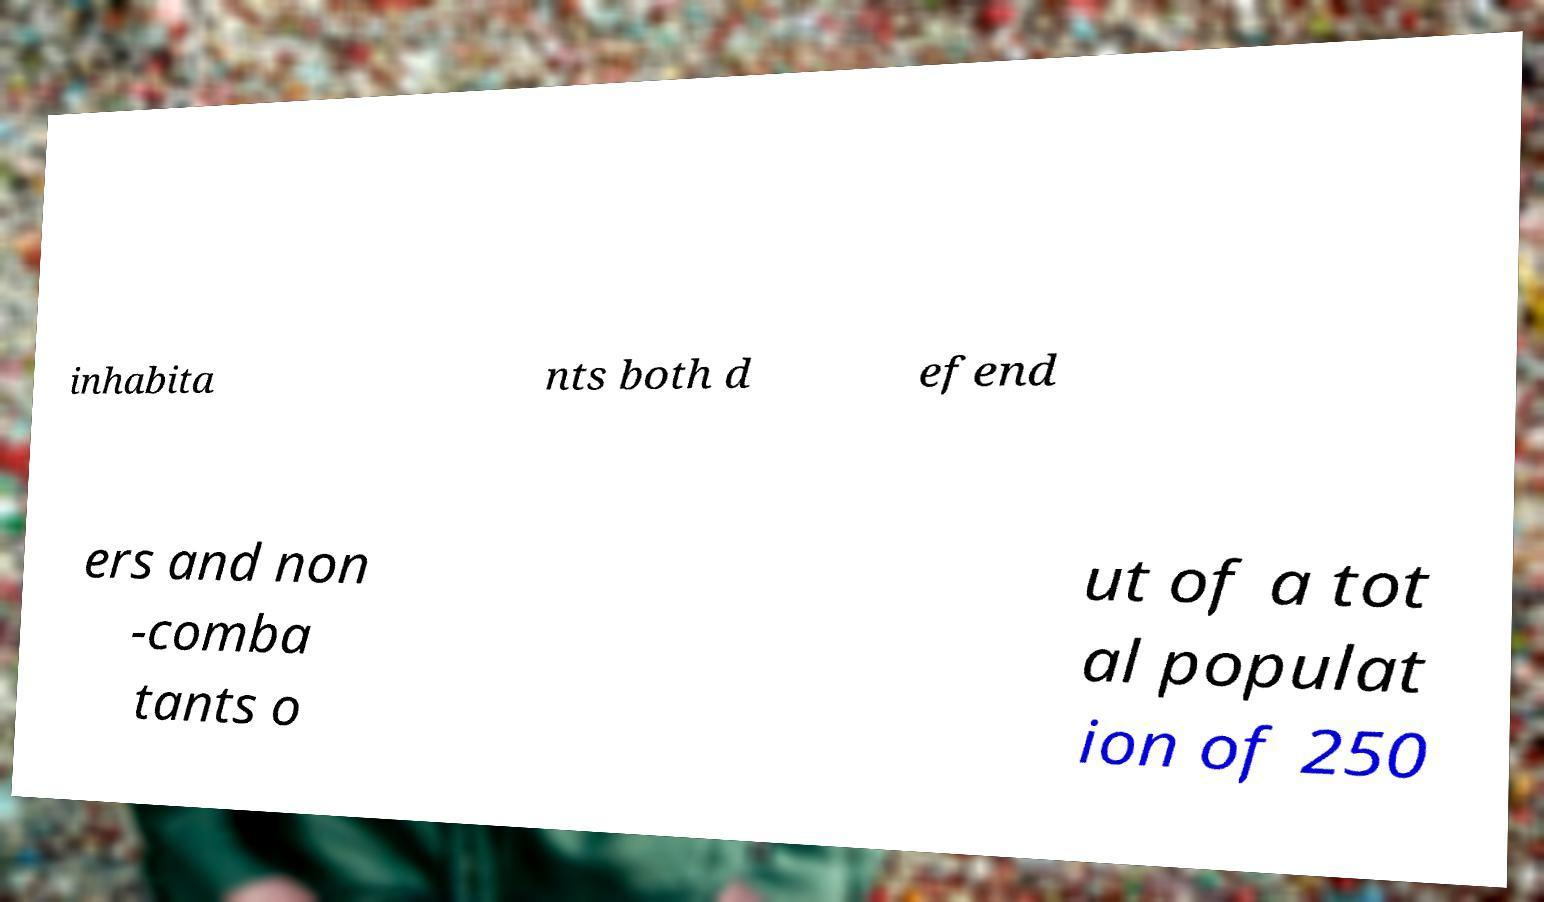Please read and relay the text visible in this image. What does it say? inhabita nts both d efend ers and non -comba tants o ut of a tot al populat ion of 250 